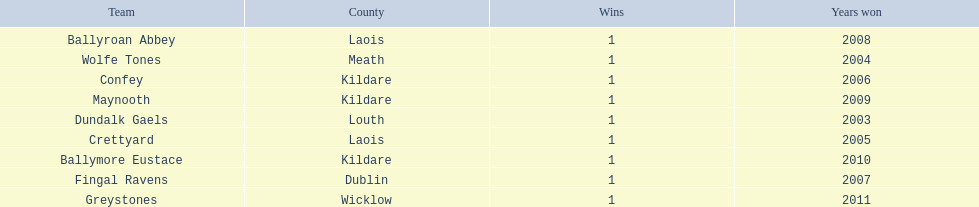What county is the team that won in 2009 from? Kildare. What is the teams name? Maynooth. 